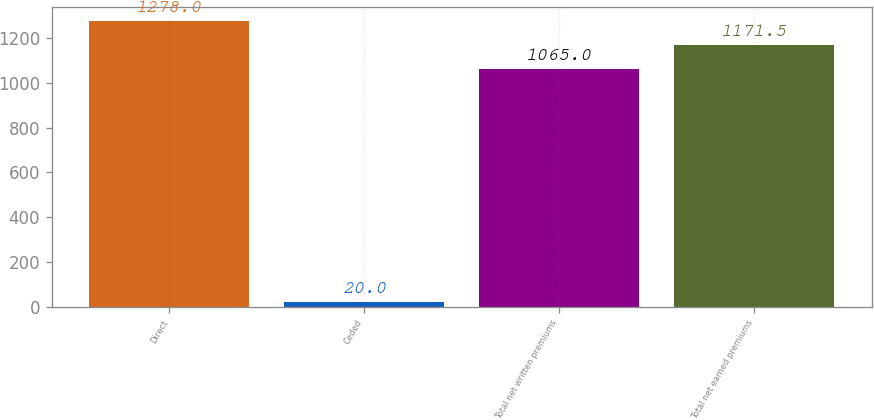Convert chart. <chart><loc_0><loc_0><loc_500><loc_500><bar_chart><fcel>Direct<fcel>Ceded<fcel>Total net written premiums<fcel>Total net earned premiums<nl><fcel>1278<fcel>20<fcel>1065<fcel>1171.5<nl></chart> 